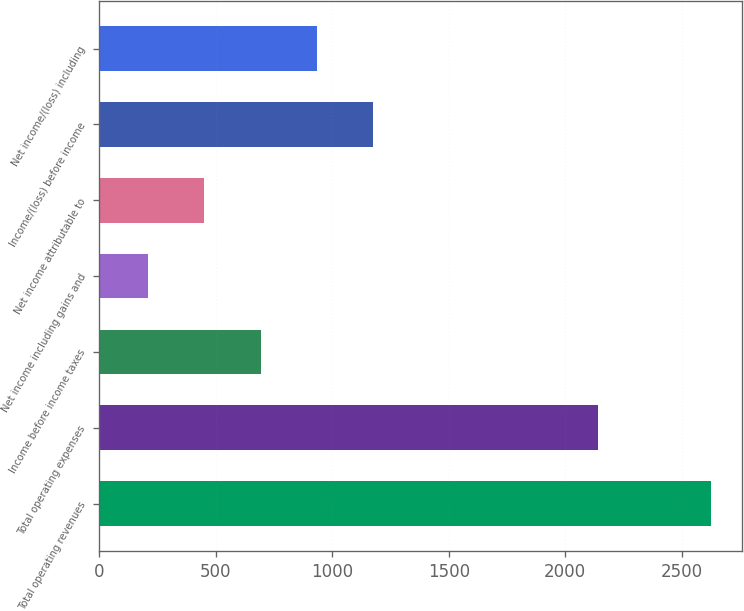Convert chart. <chart><loc_0><loc_0><loc_500><loc_500><bar_chart><fcel>Total operating revenues<fcel>Total operating expenses<fcel>Income before income taxes<fcel>Net income including gains and<fcel>Net income attributable to<fcel>Income/(loss) before income<fcel>Net income/(loss) including<nl><fcel>2627.3<fcel>2143<fcel>692.9<fcel>209.3<fcel>451.1<fcel>1176.5<fcel>934.7<nl></chart> 